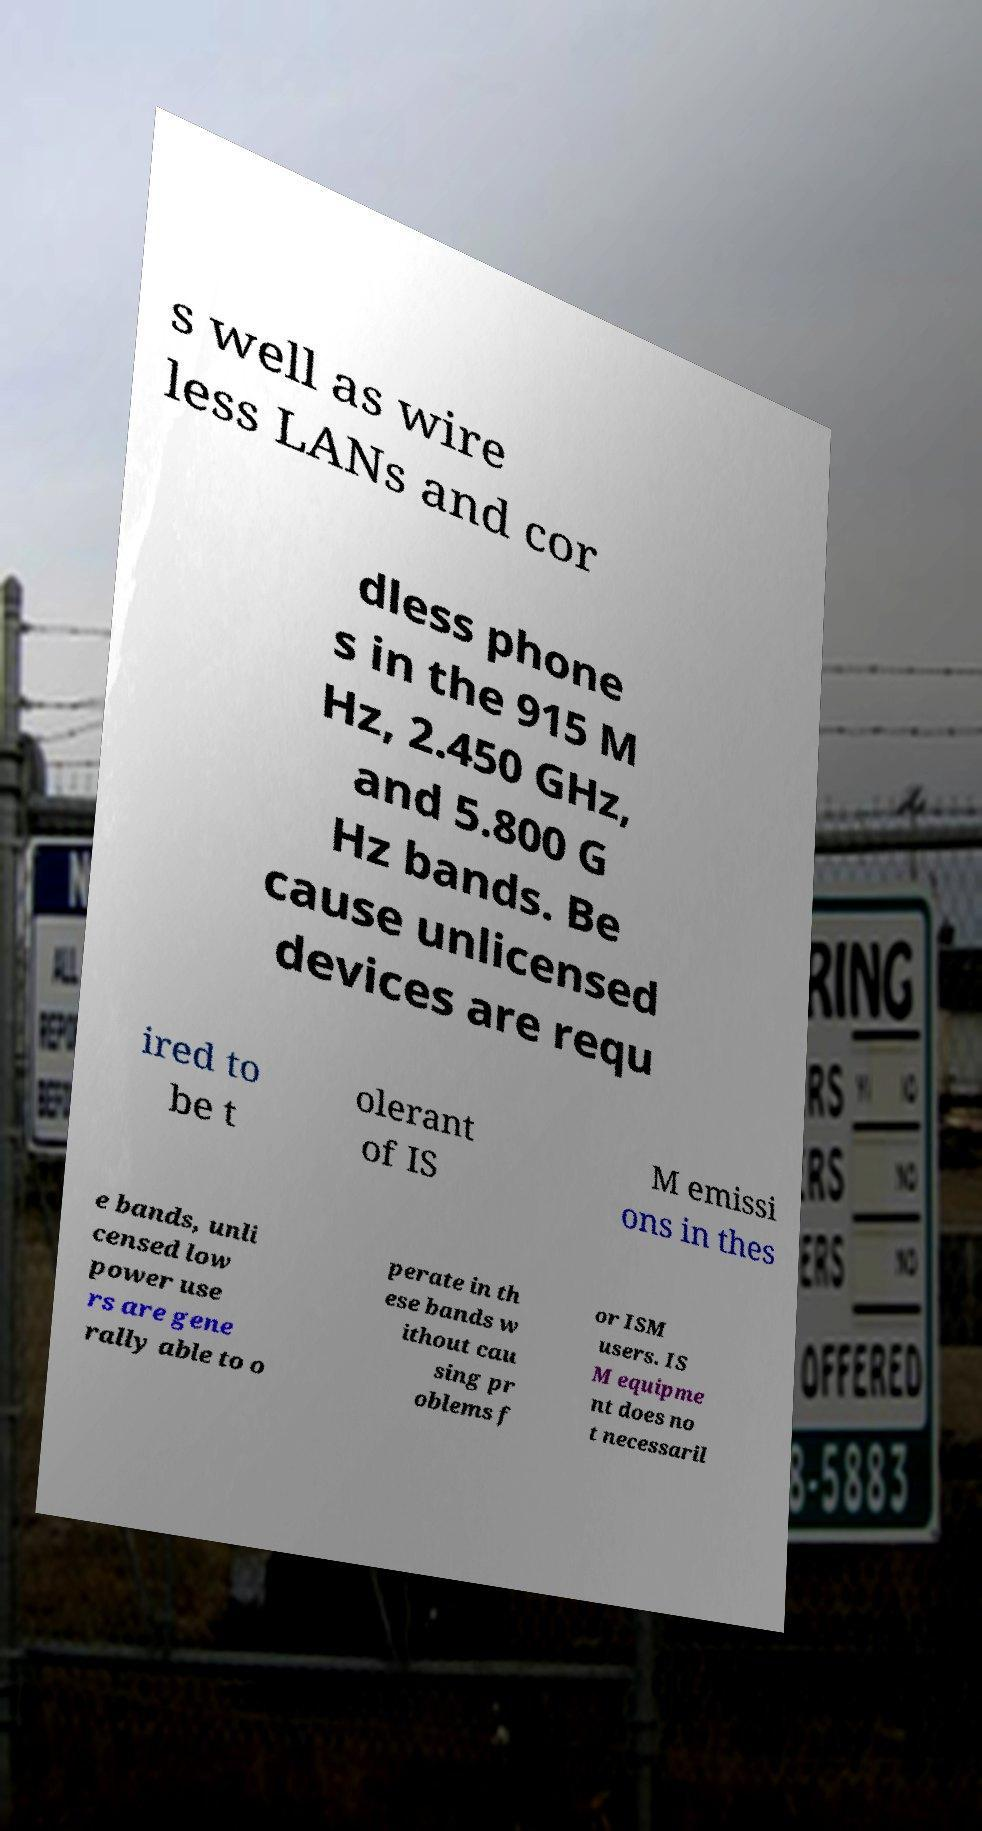Could you extract and type out the text from this image? s well as wire less LANs and cor dless phone s in the 915 M Hz, 2.450 GHz, and 5.800 G Hz bands. Be cause unlicensed devices are requ ired to be t olerant of IS M emissi ons in thes e bands, unli censed low power use rs are gene rally able to o perate in th ese bands w ithout cau sing pr oblems f or ISM users. IS M equipme nt does no t necessaril 